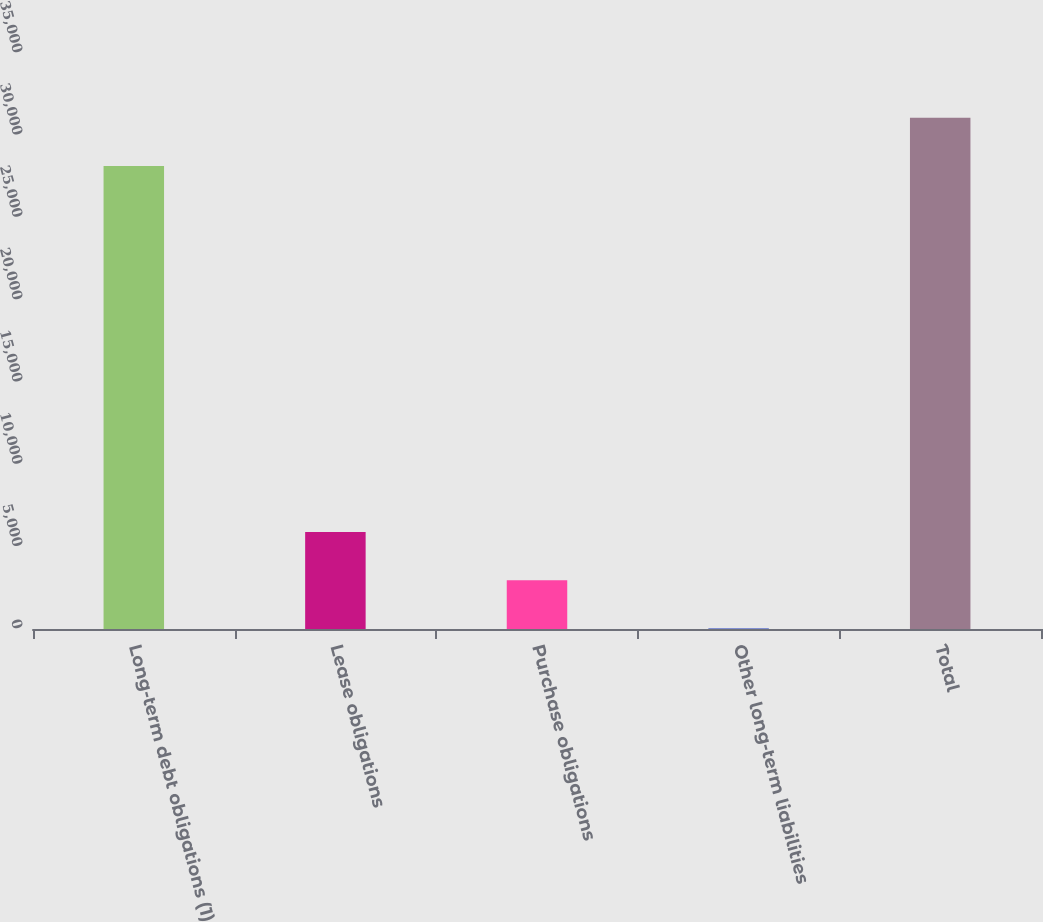Convert chart to OTSL. <chart><loc_0><loc_0><loc_500><loc_500><bar_chart><fcel>Long-term debt obligations (1)<fcel>Lease obligations<fcel>Purchase obligations<fcel>Other long-term liabilities<fcel>Total<nl><fcel>28132<fcel>5894.8<fcel>2964.9<fcel>35<fcel>31061.9<nl></chart> 